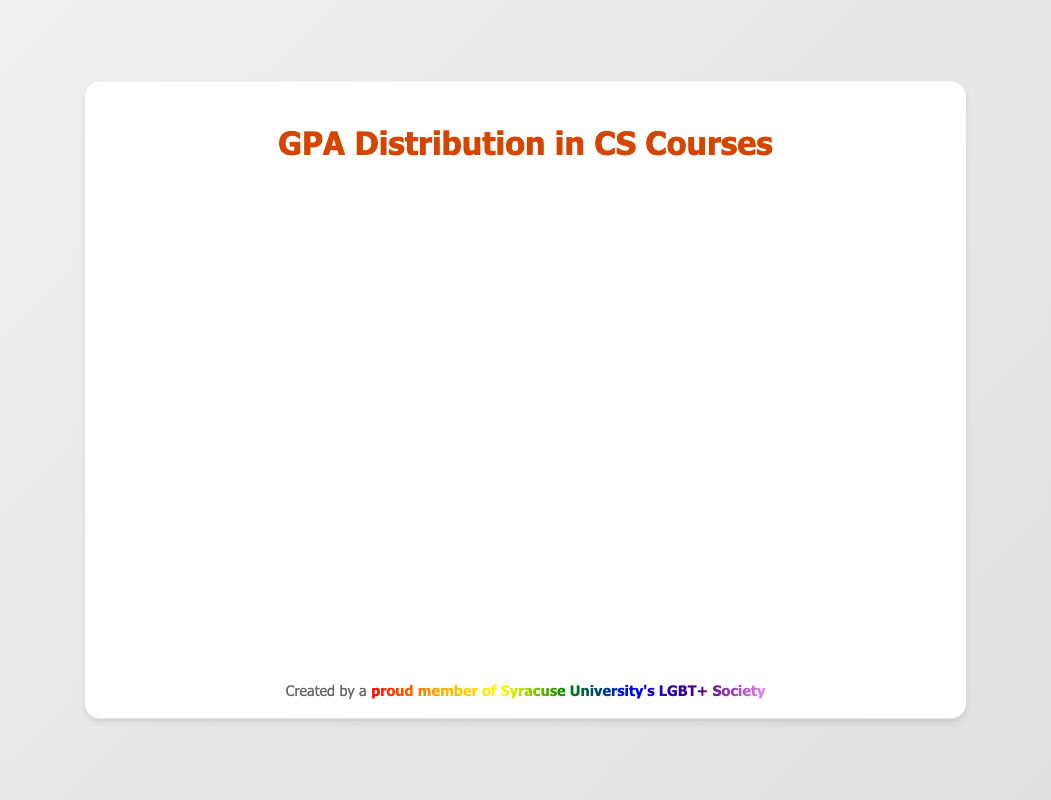What is the title of the figure? The title is usually located at the top of the chart and provides a summary of what the chart represents. Here, it is displayed prominently.
Answer: GPA Distribution Across CS Course Levels Which course has the highest median GPA? To find the course with the highest median GPA, look at the central line within each box in the plot. The median for "CSE 401" is the highest.
Answer: CSE 401 What is the lowest GPA recorded in CSE 101? The lowest GPA can be identified by the bottom whisker of the box plot for CSE 101. It extends to the minimum value.
Answer: 3.0 Compare the interquartile range (IQR) of CSE 201 and CSE 301. Which course has a larger IQR? The IQR is represented by the height of the box, which ranges from the lower quartile (Q1) to the upper quartile (Q3). CSE 201 has a more extended box than CSE 301, indicating a larger IQR.
Answer: CSE 201 What is the range of GPAs for CSE 401? The range is found by subtracting the minimum value from the maximum value, represented by the whiskers for CSE 401 (3.9 - 3.0).
Answer: 0.9 Are there any outliers in the GPA distribution of any courses? Outliers are typically represented as individual points that lie outside the whiskers. Upon inspection, there are no visible outliers in any of the courses.
Answer: No Which course has the smallest spread of GPA scores? The spread can be assessed by looking at the total length of the whiskers. CSE 401, with the smallest distance between its minimum and maximum whiskers, has the smallest spread.
Answer: CSE 401 What is the upper quartile (Q3) for CSE 301? The upper quartile is the top edge of the box. For CSE 301, this value is around 3.7.
Answer: 3.7 Which course level shows the most consistent GPA performance? Consistency can be judged by the tightness of the IQR and the short length of the whiskers. CSE 401 has the most consistent performance with the smallest IQR and whisker range.
Answer: CSE 401 